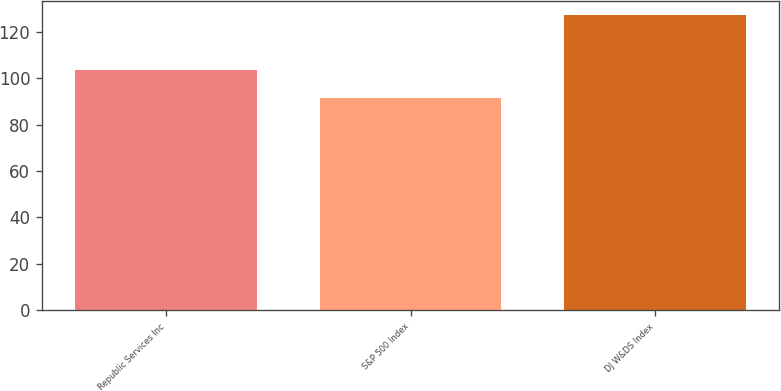Convert chart to OTSL. <chart><loc_0><loc_0><loc_500><loc_500><bar_chart><fcel>Republic Services Inc<fcel>S&P 500 Index<fcel>DJ W&DS Index<nl><fcel>103.61<fcel>91.64<fcel>126.99<nl></chart> 